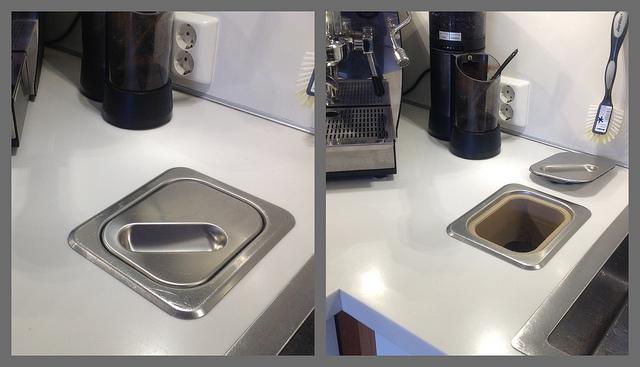Is the counter white?
Be succinct. Yes. Is the lid on or off in the second picture?
Short answer required. Off. Is anyone preparing food?
Answer briefly. No. 